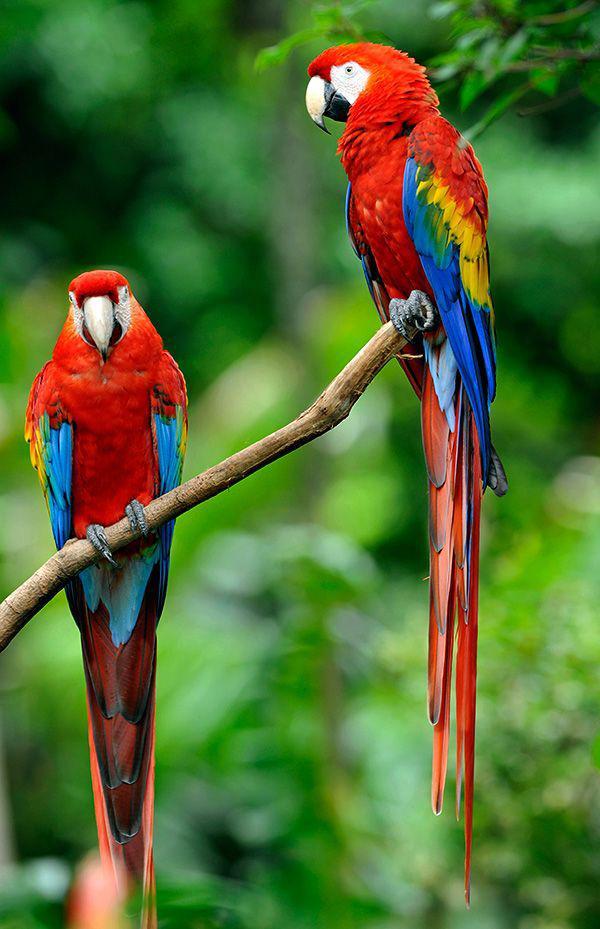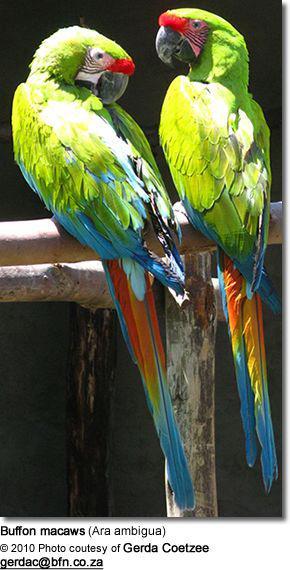The first image is the image on the left, the second image is the image on the right. Examine the images to the left and right. Is the description "In one image, two teal colored parrots are sitting together on a tree branch." accurate? Answer yes or no. No. The first image is the image on the left, the second image is the image on the right. Considering the images on both sides, is "There are two birds in the image on the right." valid? Answer yes or no. Yes. The first image is the image on the left, the second image is the image on the right. For the images displayed, is the sentence "A total of three parrots are depicted in the images." factually correct? Answer yes or no. No. 